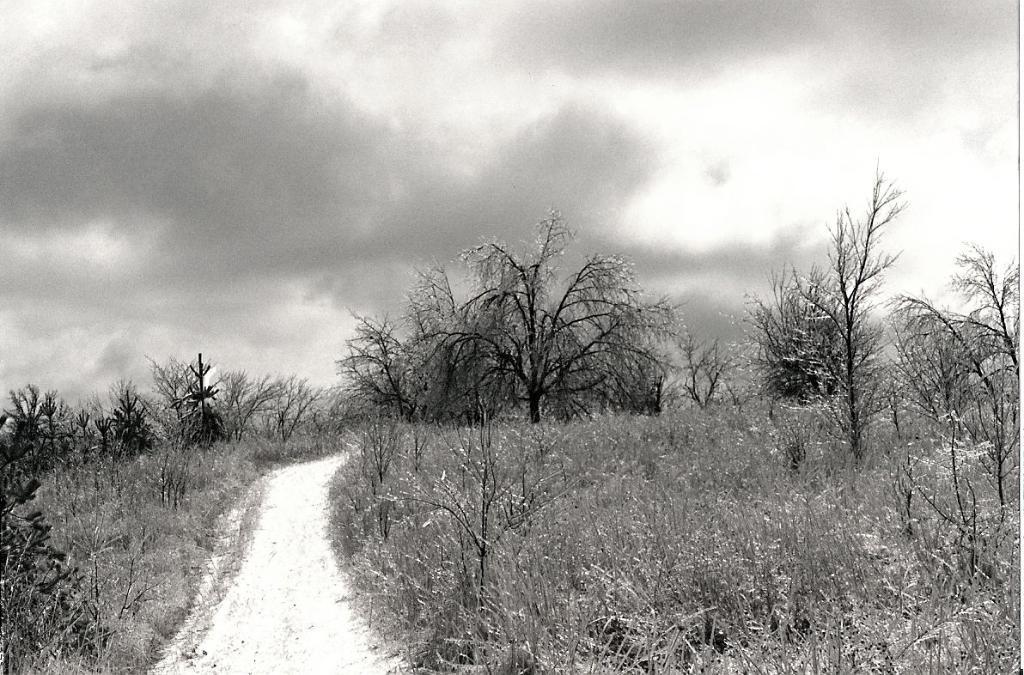Can you describe this image briefly? In this black and white image there is a path. On the right and left side of the image there are trees and grass. In the background there is a sky. 